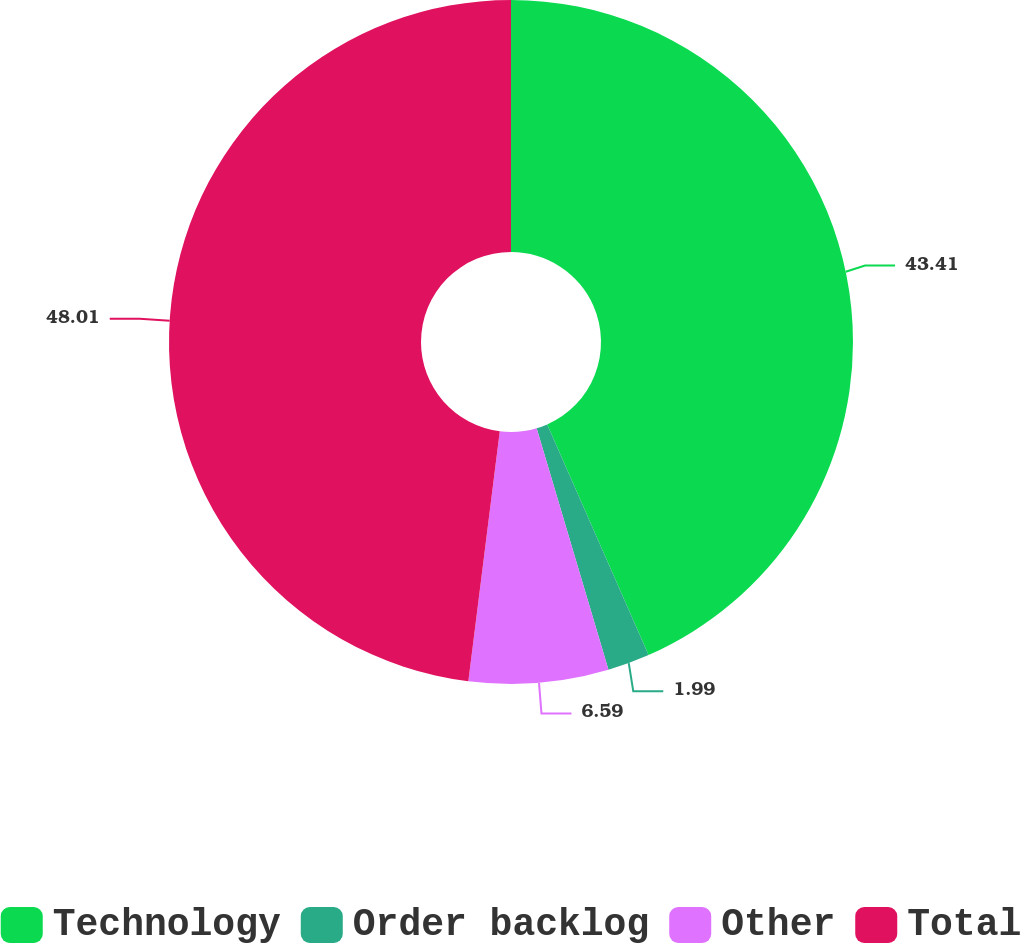<chart> <loc_0><loc_0><loc_500><loc_500><pie_chart><fcel>Technology<fcel>Order backlog<fcel>Other<fcel>Total<nl><fcel>43.41%<fcel>1.99%<fcel>6.59%<fcel>48.01%<nl></chart> 